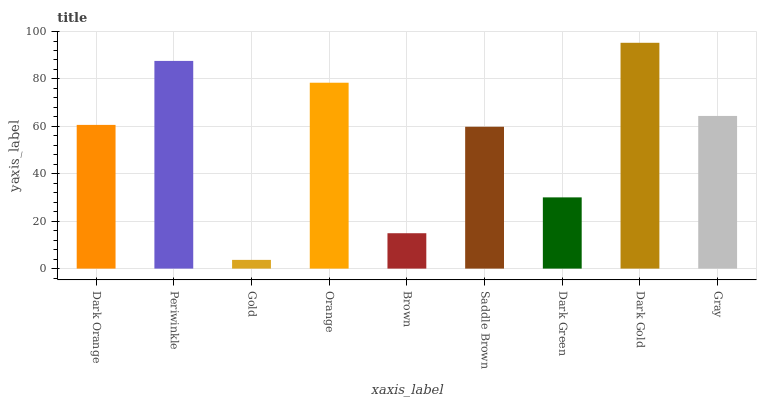Is Gold the minimum?
Answer yes or no. Yes. Is Dark Gold the maximum?
Answer yes or no. Yes. Is Periwinkle the minimum?
Answer yes or no. No. Is Periwinkle the maximum?
Answer yes or no. No. Is Periwinkle greater than Dark Orange?
Answer yes or no. Yes. Is Dark Orange less than Periwinkle?
Answer yes or no. Yes. Is Dark Orange greater than Periwinkle?
Answer yes or no. No. Is Periwinkle less than Dark Orange?
Answer yes or no. No. Is Dark Orange the high median?
Answer yes or no. Yes. Is Dark Orange the low median?
Answer yes or no. Yes. Is Orange the high median?
Answer yes or no. No. Is Brown the low median?
Answer yes or no. No. 